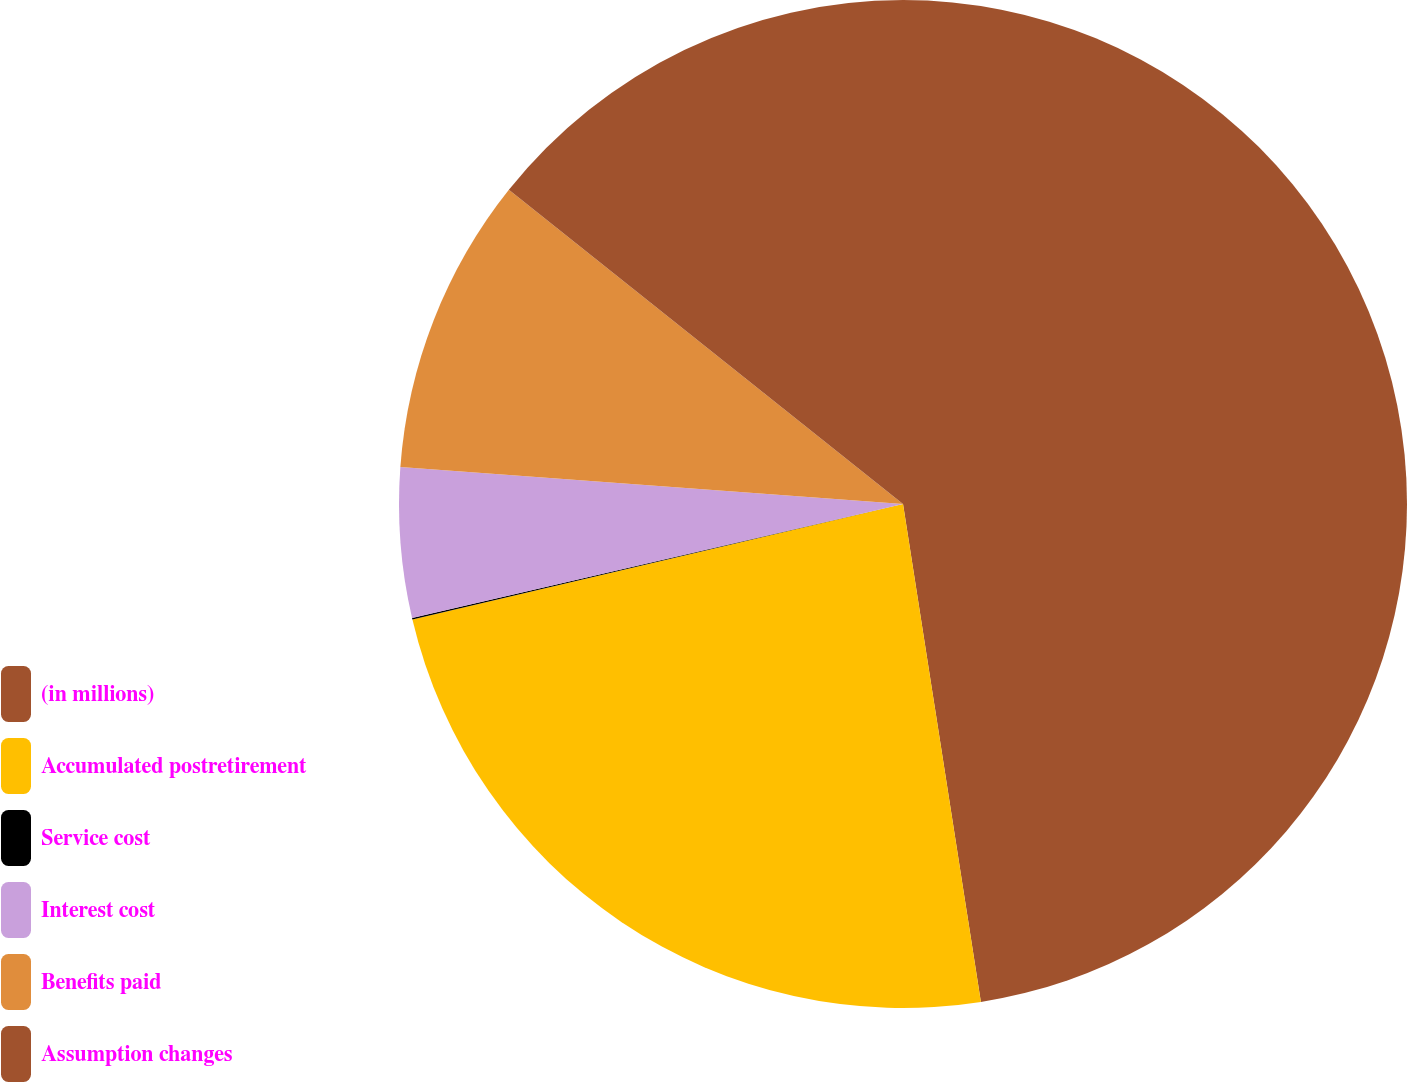<chart> <loc_0><loc_0><loc_500><loc_500><pie_chart><fcel>(in millions)<fcel>Accumulated postretirement<fcel>Service cost<fcel>Interest cost<fcel>Benefits paid<fcel>Assumption changes<nl><fcel>47.53%<fcel>23.79%<fcel>0.05%<fcel>4.8%<fcel>9.54%<fcel>14.29%<nl></chart> 